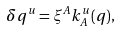Convert formula to latex. <formula><loc_0><loc_0><loc_500><loc_500>\delta q ^ { u } = \xi ^ { A } k _ { A } ^ { u } ( q ) ,</formula> 